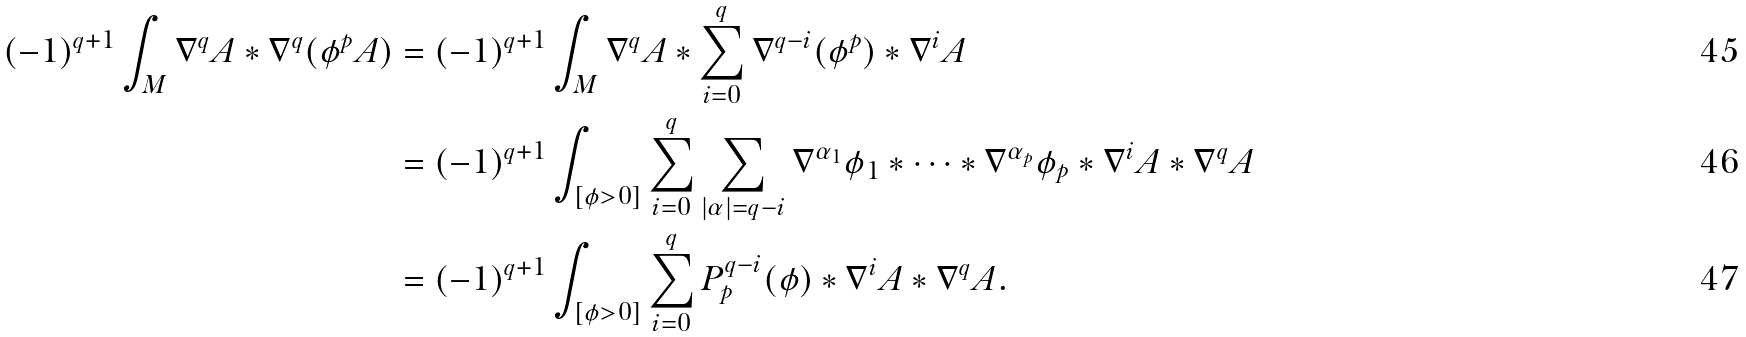<formula> <loc_0><loc_0><loc_500><loc_500>( - 1 ) ^ { q + 1 } \int _ { M } \nabla ^ { q } A * \nabla ^ { q } ( \phi ^ { p } A ) & = ( - 1 ) ^ { q + 1 } \int _ { M } \nabla ^ { q } A * \sum _ { i = 0 } ^ { q } \nabla ^ { q - i } ( \phi ^ { p } ) * \nabla ^ { i } A \\ & = ( - 1 ) ^ { q + 1 } \int _ { [ \phi > 0 ] } \sum _ { i = 0 } ^ { q } \sum _ { | \alpha | = q - i } \nabla ^ { \alpha _ { 1 } } \phi _ { 1 } * \cdots * \nabla ^ { \alpha _ { p } } \phi _ { p } * \nabla ^ { i } A * \nabla ^ { q } A \\ & = ( - 1 ) ^ { q + 1 } \int _ { [ \phi > 0 ] } \sum _ { i = 0 } ^ { q } P _ { p } ^ { q - i } ( \phi ) * \nabla ^ { i } A * \nabla ^ { q } A .</formula> 